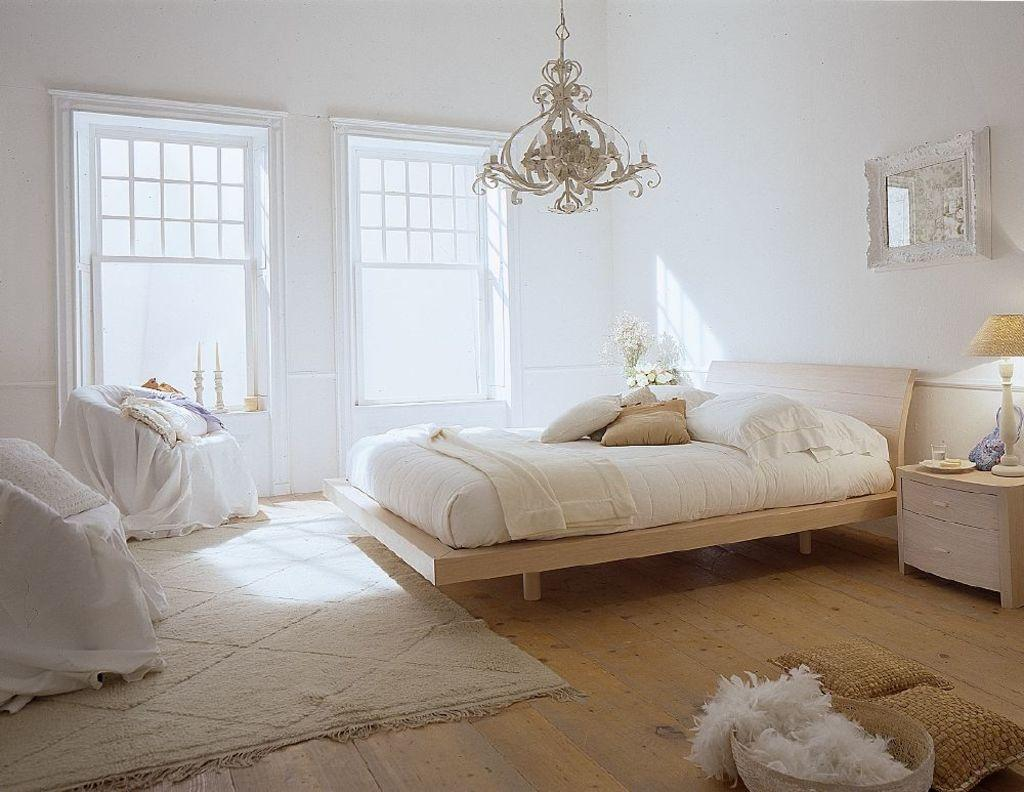What type of furniture is present in the image? There is a bed and chairs in the image. What is placed on the bed? Pillows are on the bed. What is the color of the walls in the image? The walls are white in color. Can you describe an accessory present in the image? There is a soft feather band in the image. Where is the soft feather band stored? The soft feather band is kept in a basket on the floor. How many pickles are on the bed? There are no pickles present in the image. 